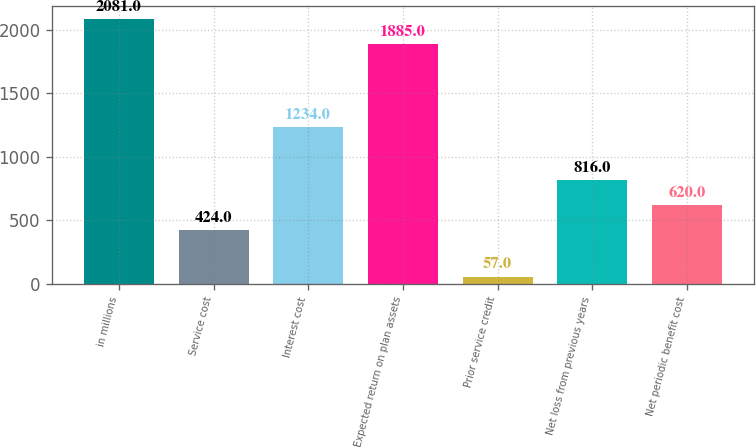Convert chart to OTSL. <chart><loc_0><loc_0><loc_500><loc_500><bar_chart><fcel>in millions<fcel>Service cost<fcel>Interest cost<fcel>Expected return on plan assets<fcel>Prior service credit<fcel>Net loss from previous years<fcel>Net periodic benefit cost<nl><fcel>2081<fcel>424<fcel>1234<fcel>1885<fcel>57<fcel>816<fcel>620<nl></chart> 